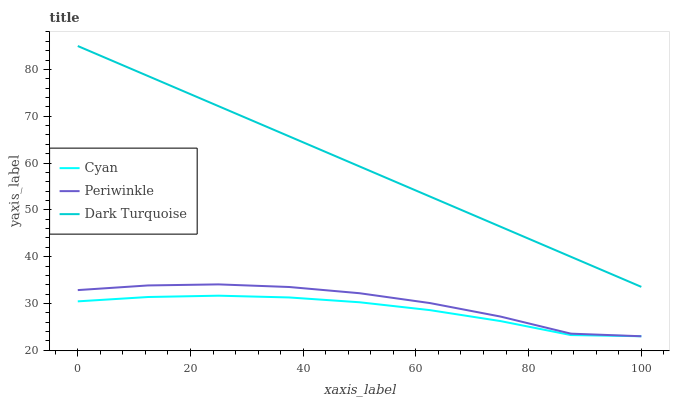Does Cyan have the minimum area under the curve?
Answer yes or no. Yes. Does Dark Turquoise have the maximum area under the curve?
Answer yes or no. Yes. Does Periwinkle have the minimum area under the curve?
Answer yes or no. No. Does Periwinkle have the maximum area under the curve?
Answer yes or no. No. Is Dark Turquoise the smoothest?
Answer yes or no. Yes. Is Periwinkle the roughest?
Answer yes or no. Yes. Is Periwinkle the smoothest?
Answer yes or no. No. Is Dark Turquoise the roughest?
Answer yes or no. No. Does Dark Turquoise have the lowest value?
Answer yes or no. No. Does Dark Turquoise have the highest value?
Answer yes or no. Yes. Does Periwinkle have the highest value?
Answer yes or no. No. Is Cyan less than Dark Turquoise?
Answer yes or no. Yes. Is Dark Turquoise greater than Cyan?
Answer yes or no. Yes. Does Cyan intersect Dark Turquoise?
Answer yes or no. No. 